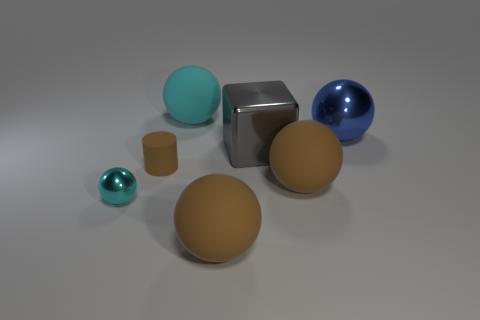Subtract all blue spheres. How many spheres are left? 4 Subtract all large blue balls. How many balls are left? 4 Subtract all red cubes. Subtract all red cylinders. How many cubes are left? 1 Add 3 yellow rubber blocks. How many objects exist? 10 Subtract all cubes. How many objects are left? 6 Add 2 large metallic spheres. How many large metallic spheres are left? 3 Add 4 tiny cyan objects. How many tiny cyan objects exist? 5 Subtract 0 yellow balls. How many objects are left? 7 Subtract all brown balls. Subtract all tiny cyan metal balls. How many objects are left? 4 